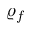Convert formula to latex. <formula><loc_0><loc_0><loc_500><loc_500>\varrho _ { f }</formula> 